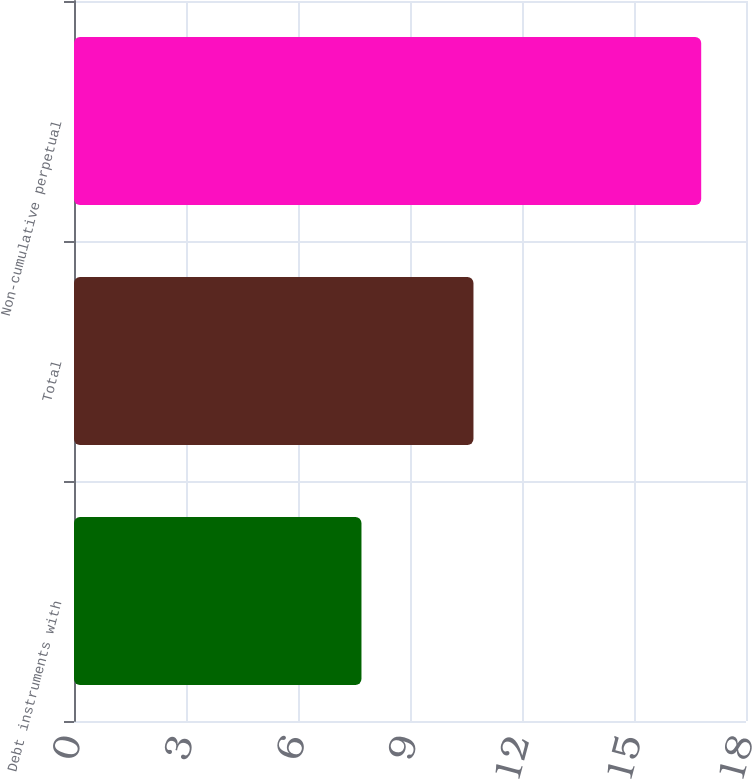<chart> <loc_0><loc_0><loc_500><loc_500><bar_chart><fcel>Debt instruments with<fcel>Total<fcel>Non-cumulative perpetual<nl><fcel>7.7<fcel>10.7<fcel>16.8<nl></chart> 